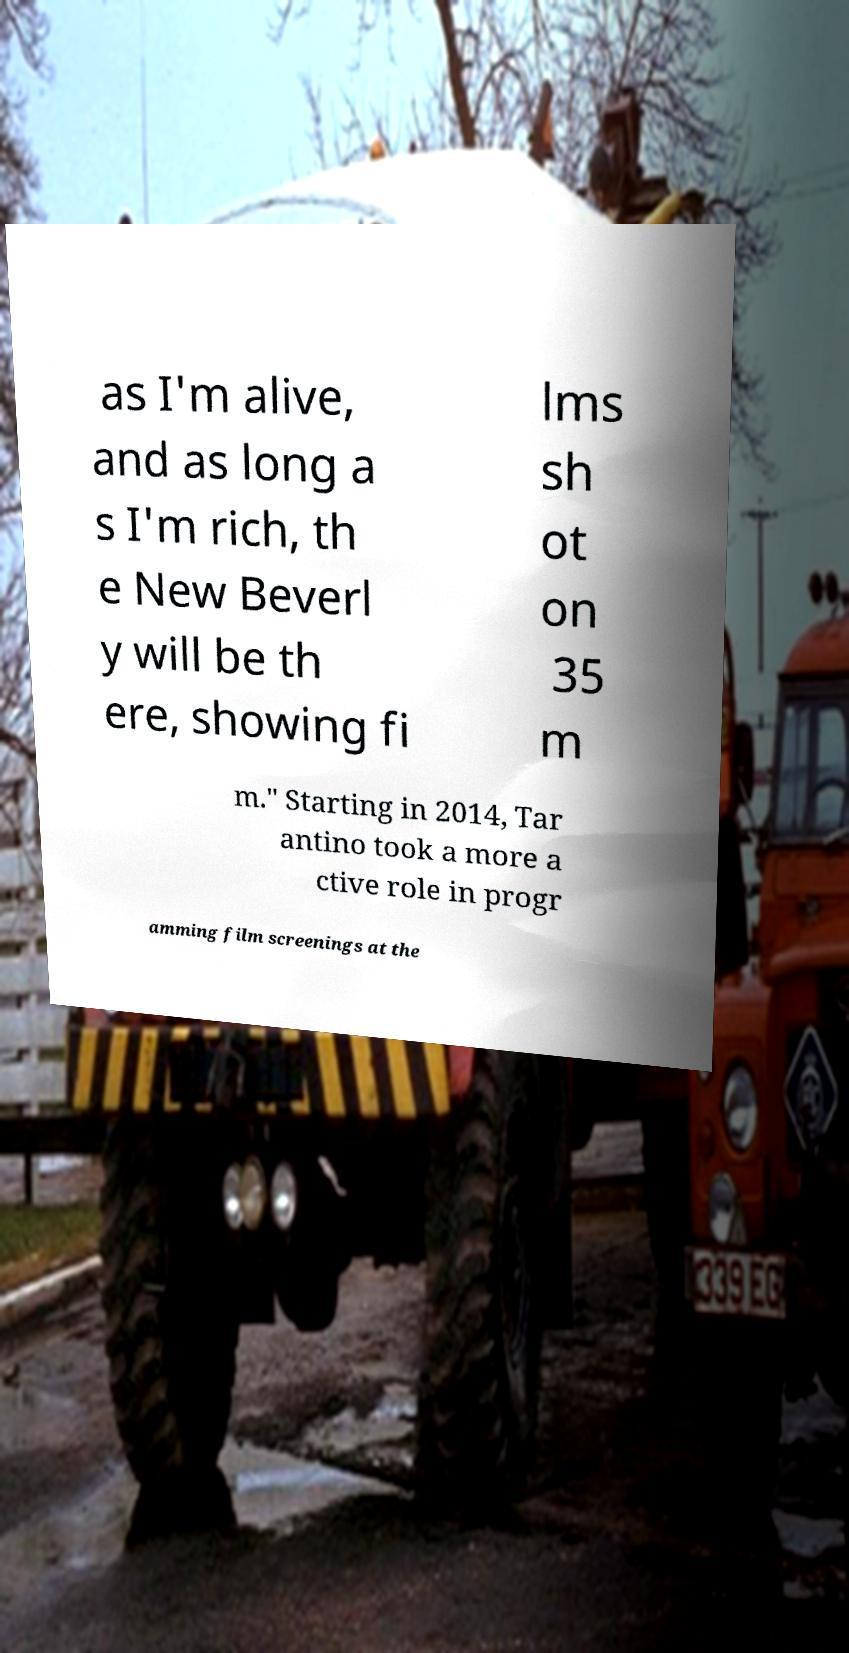There's text embedded in this image that I need extracted. Can you transcribe it verbatim? as I'm alive, and as long a s I'm rich, th e New Beverl y will be th ere, showing fi lms sh ot on 35 m m." Starting in 2014, Tar antino took a more a ctive role in progr amming film screenings at the 